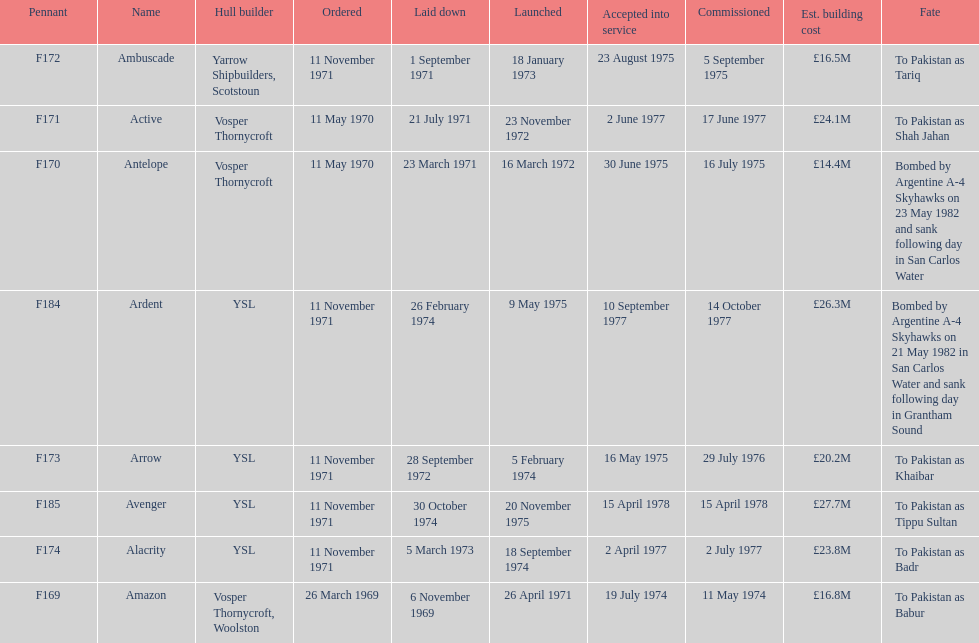Which maritime craft had the highest expected expenditure for building? Avenger. 